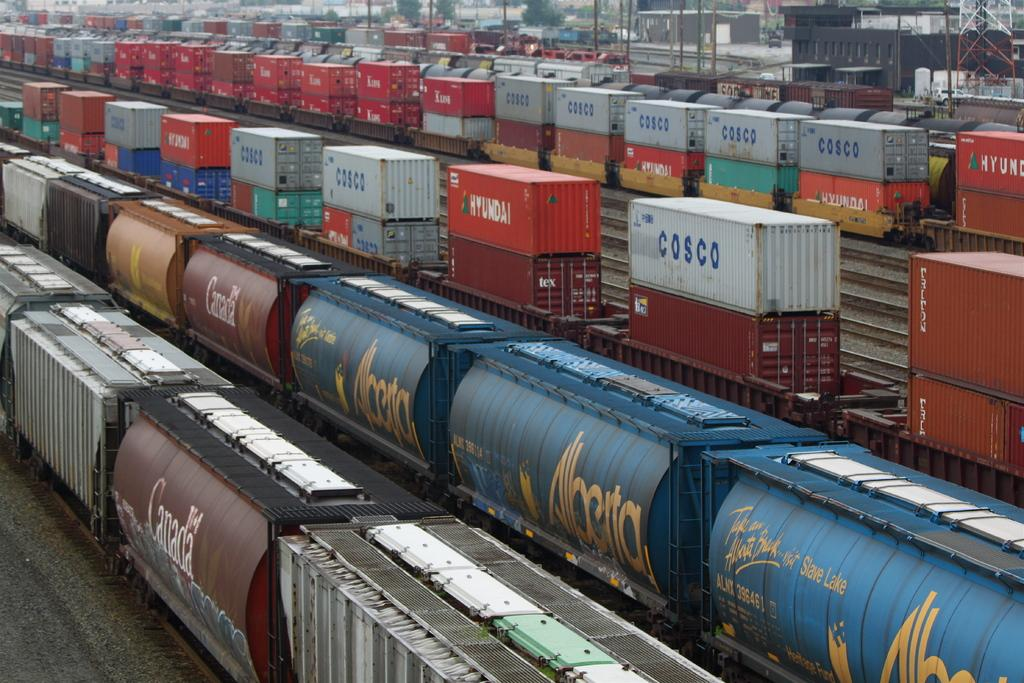<image>
Provide a brief description of the given image. A yard full of shipping crates has several from COSCO. 